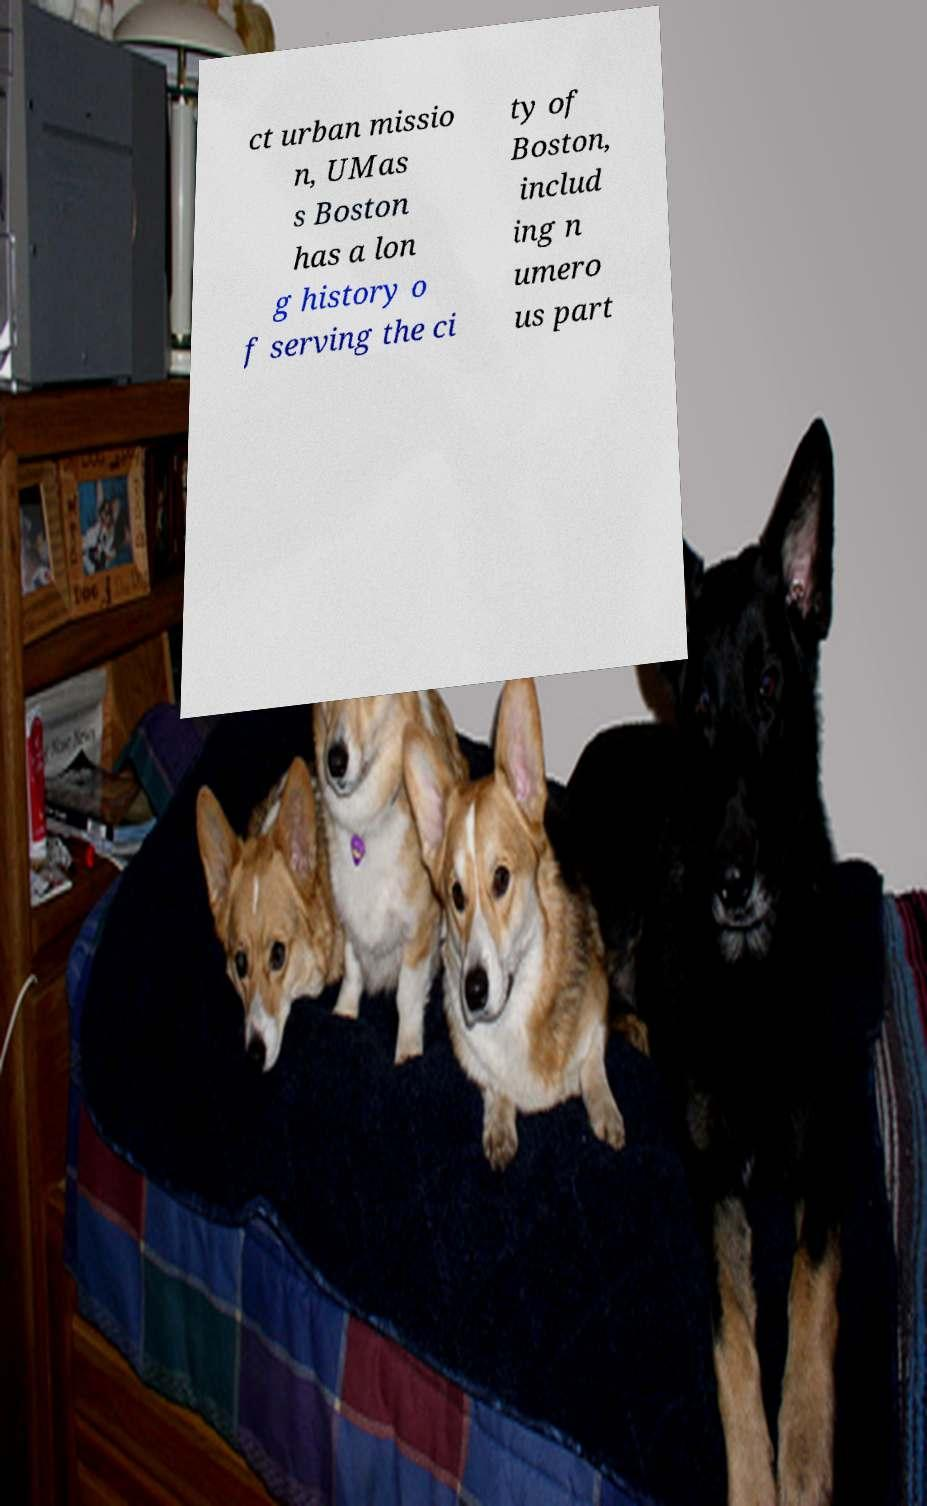I need the written content from this picture converted into text. Can you do that? ct urban missio n, UMas s Boston has a lon g history o f serving the ci ty of Boston, includ ing n umero us part 